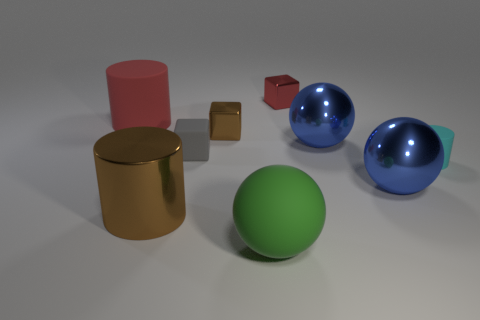What is the shape of the red matte thing that is the same size as the green object?
Your response must be concise. Cylinder. Is there a blue metallic sphere left of the metal ball that is behind the blue sphere in front of the small gray thing?
Give a very brief answer. No. Is there a brown cylinder of the same size as the green object?
Your answer should be very brief. Yes. How big is the cylinder on the right side of the large brown shiny cylinder?
Your response must be concise. Small. What color is the large sphere left of the cube that is behind the shiny block that is in front of the red rubber cylinder?
Your answer should be compact. Green. What color is the small block that is in front of the brown object that is on the right side of the large brown thing?
Provide a short and direct response. Gray. Is the number of big blue objects that are behind the tiny rubber block greater than the number of blue metal things in front of the rubber ball?
Provide a succinct answer. Yes. Is the material of the big blue thing in front of the tiny rubber cylinder the same as the big sphere behind the cyan matte thing?
Provide a short and direct response. Yes. Are there any red things in front of the small red metallic thing?
Provide a short and direct response. Yes. How many yellow things are metallic spheres or big rubber balls?
Your answer should be very brief. 0. 